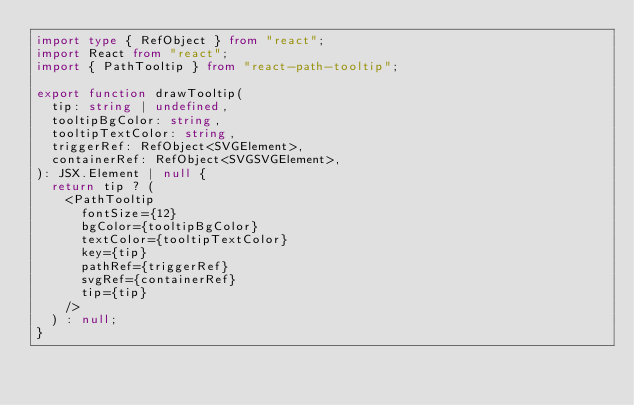<code> <loc_0><loc_0><loc_500><loc_500><_TypeScript_>import type { RefObject } from "react";
import React from "react";
import { PathTooltip } from "react-path-tooltip";

export function drawTooltip(
  tip: string | undefined,
  tooltipBgColor: string,
  tooltipTextColor: string,
  triggerRef: RefObject<SVGElement>,
  containerRef: RefObject<SVGSVGElement>,
): JSX.Element | null {
  return tip ? (
    <PathTooltip
      fontSize={12}
      bgColor={tooltipBgColor}
      textColor={tooltipTextColor}
      key={tip}
      pathRef={triggerRef}
      svgRef={containerRef}
      tip={tip}
    />
  ) : null;
}
</code> 